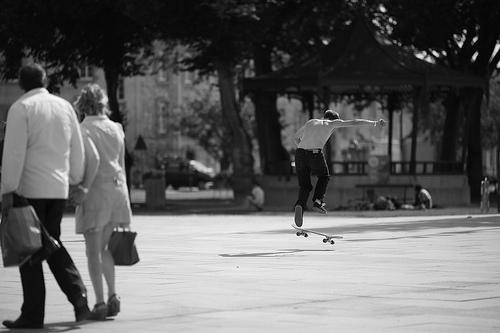Count the number of noticeable objects in the image. There are 32 distinct objects in the image. Mention the color of the handbag and the type of pants worn by the skateboarder. The handbag is dark colored, and the skateboarder is wearing dark-colored pants. Analyze the sentiment conveyed by the image. The image depicts excitement and action, as the skateboarder performs a trick. Perform complex reasoning by analyzing the skateboarder's clothing items and their properties. The skateboarder is shirtless, wears a pair of dark-colored pants (or black jeans), and is in the middle of performing a trick on the skateboard. Describe the motion of the skateboard and its position relative to the skateboarder. The skateboard is mid-air, positioned under the skateboarder performing a trick. List all the objects present in the image. Skateboarder, skateboard, shirtless skateboarder, pair of pants, pair of black jeans, couple walking, large women's purse, large shopping bag, picnic table, traffic yield sign, woman swinging a tennis racket, man jumping over skateboard, two people at skatepark, woman holding handbag, man holding bags. How many tennis racket swinging women are shown in the image? There are 10 instances of a woman in white swinging a tennis racket. Identify the object being carried by the man and woman walking together. The man is carrying a bag, and the woman is holding a handbag. Discuss the interaction between the man and woman walking together. The man and woman are walking while holding hands and carrying bags. What is the main focus of the image? A skateboarder performing a trick in mid-air. 